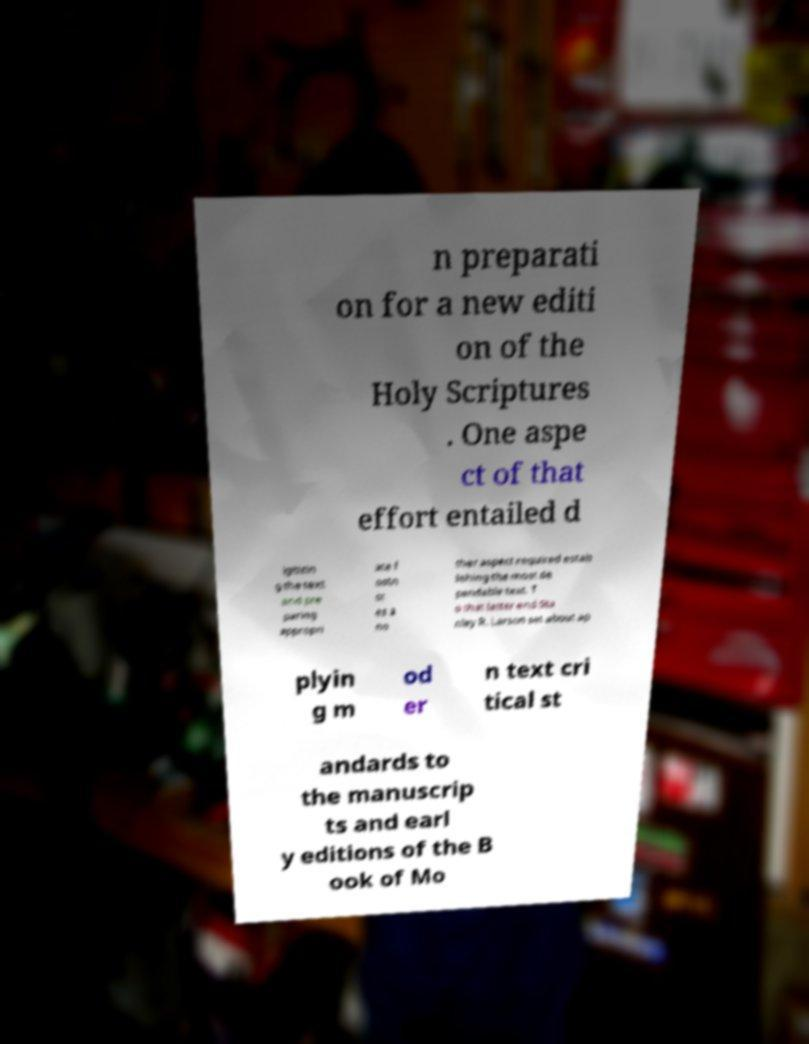I need the written content from this picture converted into text. Can you do that? n preparati on for a new editi on of the Holy Scriptures . One aspe ct of that effort entailed d igitizin g the text and pre paring appropri ate f ootn ot es a no ther aspect required estab lishing the most de pendable text. T o that latter end Sta nley R. Larson set about ap plyin g m od er n text cri tical st andards to the manuscrip ts and earl y editions of the B ook of Mo 